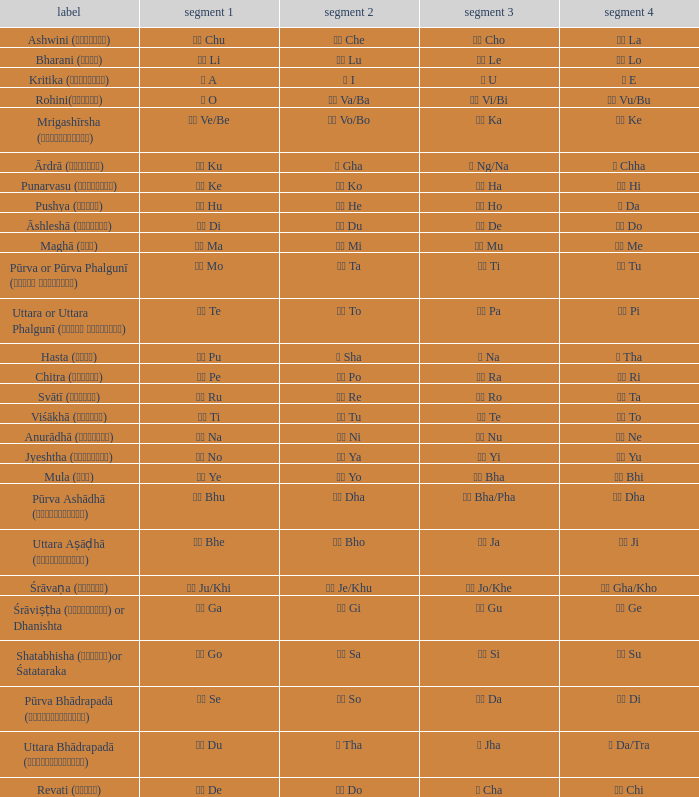Which pada 4 has a pada 2 of थ tha? ञ Da/Tra. 